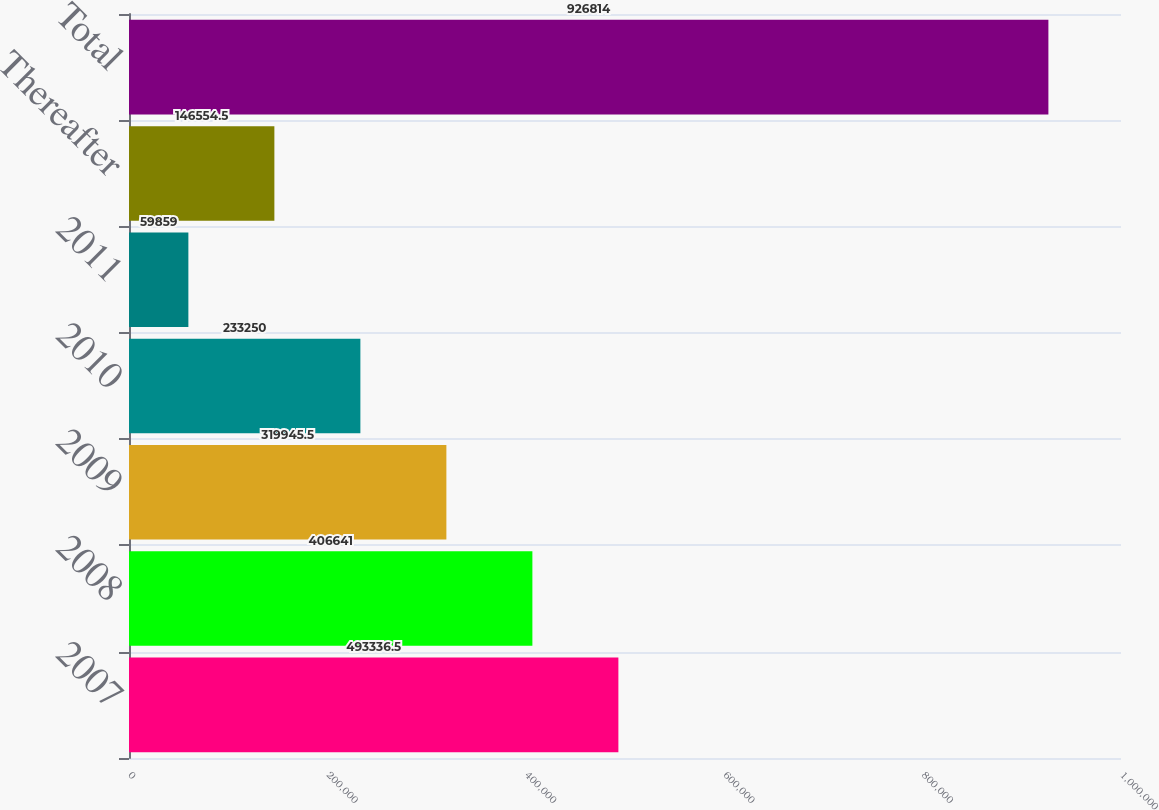Convert chart to OTSL. <chart><loc_0><loc_0><loc_500><loc_500><bar_chart><fcel>2007<fcel>2008<fcel>2009<fcel>2010<fcel>2011<fcel>Thereafter<fcel>Total<nl><fcel>493336<fcel>406641<fcel>319946<fcel>233250<fcel>59859<fcel>146554<fcel>926814<nl></chart> 